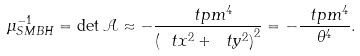<formula> <loc_0><loc_0><loc_500><loc_500>\mu ^ { - 1 } _ { S M B H } = \det \mathcal { A } \approx - \frac { \ t p m ^ { 4 } } { \left ( \ t x ^ { 2 } + \ t y ^ { 2 } \right ) ^ { 2 } } = - \frac { \ t p m ^ { 4 } } { \theta ^ { 4 } } .</formula> 